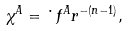Convert formula to latex. <formula><loc_0><loc_0><loc_500><loc_500>\chi ^ { A } = \dot { \ } f ^ { A } r ^ { - ( n - 1 ) } ,</formula> 